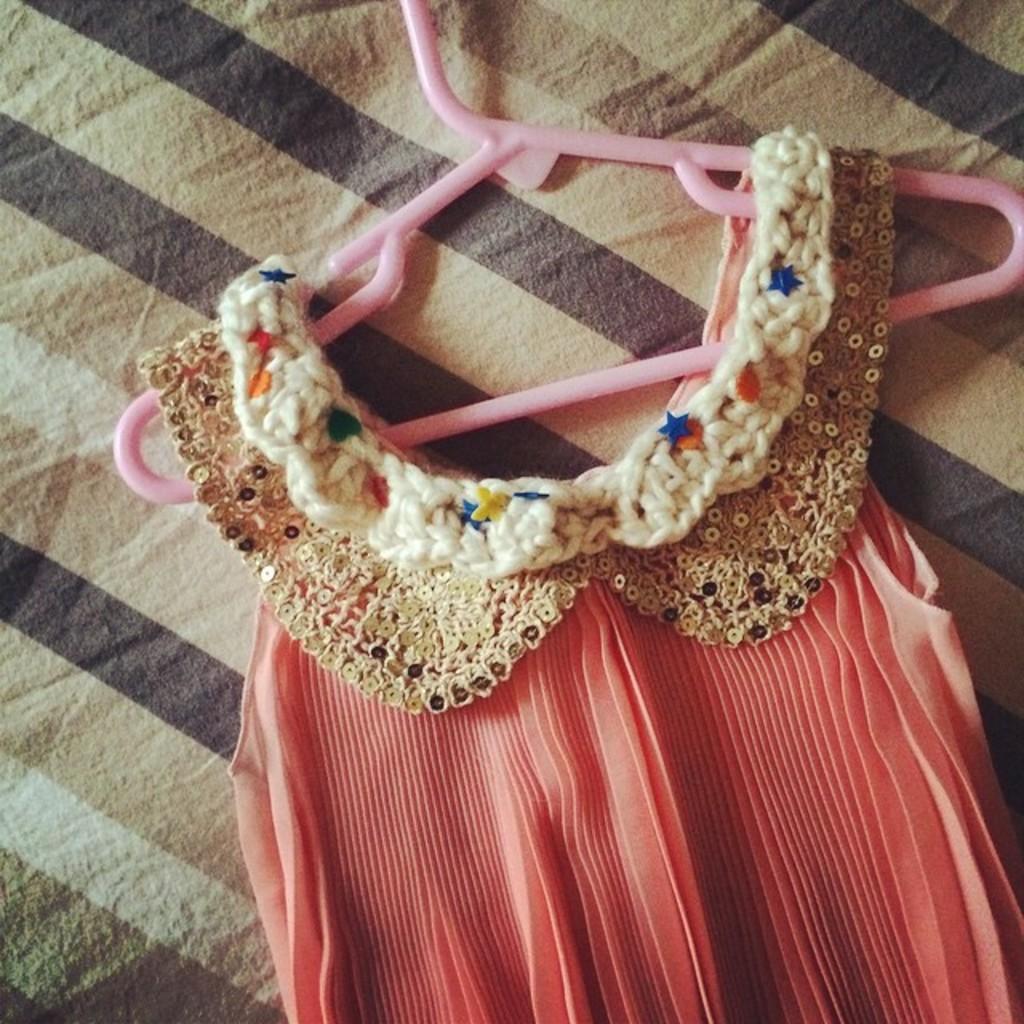Could you give a brief overview of what you see in this image? In the picture we can see a dress to the hanger which is placed on the cloth. 